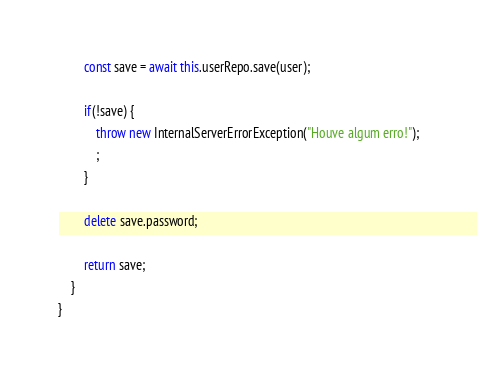Convert code to text. <code><loc_0><loc_0><loc_500><loc_500><_TypeScript_>        const save = await this.userRepo.save(user);

        if(!save) {
            throw new InternalServerErrorException("Houve algum erro!");
            ;
        }

        delete save.password;

        return save;
    }
}
</code> 